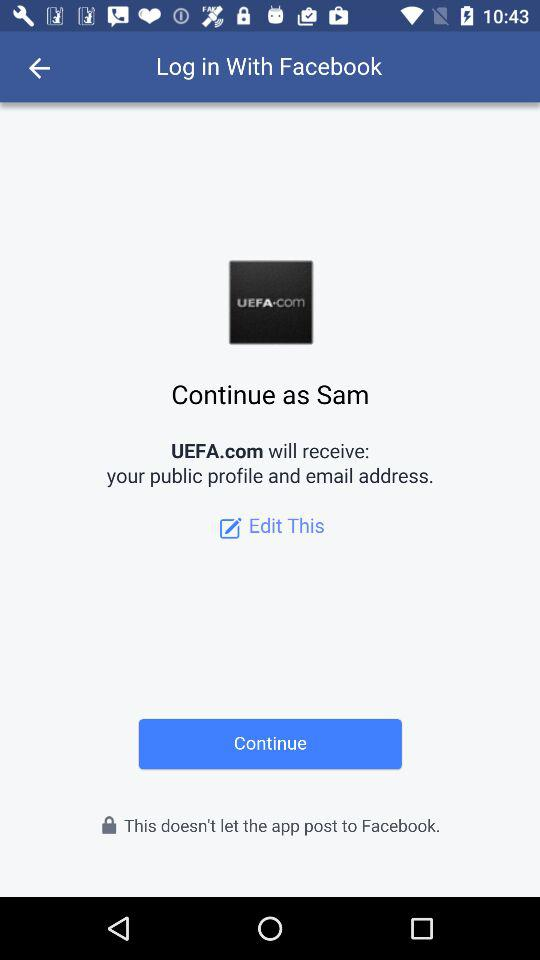What is the user name? The user name is Sam. 